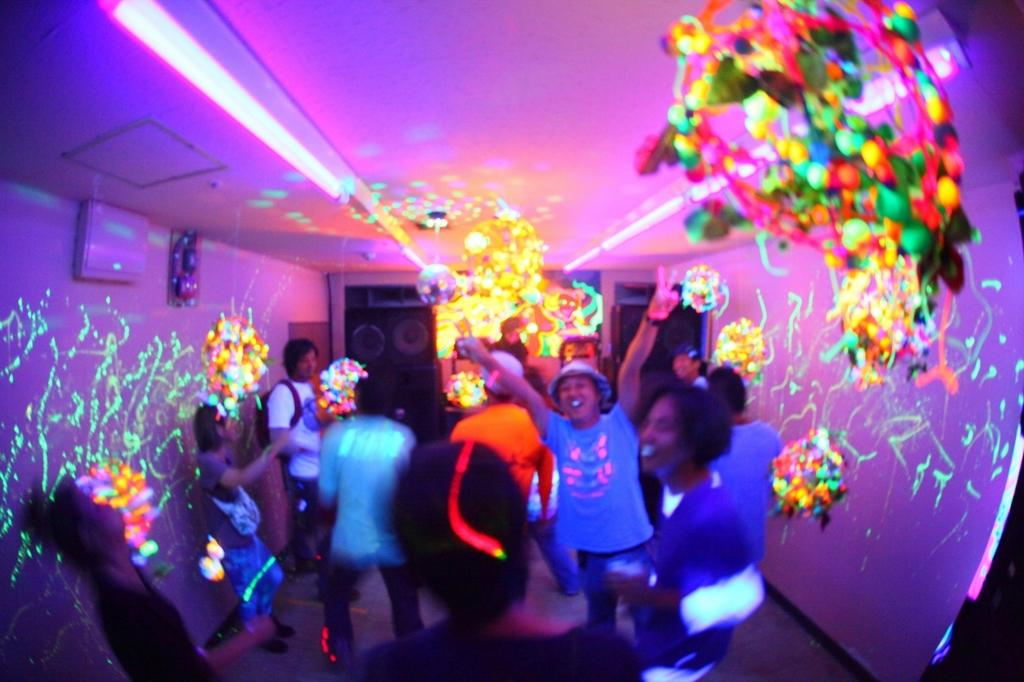Who or what is present in the image? There are people in the image. Where are the people located? The people are in one place. What can be seen in the image besides the people? There are colorful lights and decorative items in the image. What type of religion is being practiced in the image? There is no indication of any religious practice in the image. Can you see any icicles hanging from the decorative items in the image? There is no mention of icicles in the provided facts, and they are not visible in the image. 